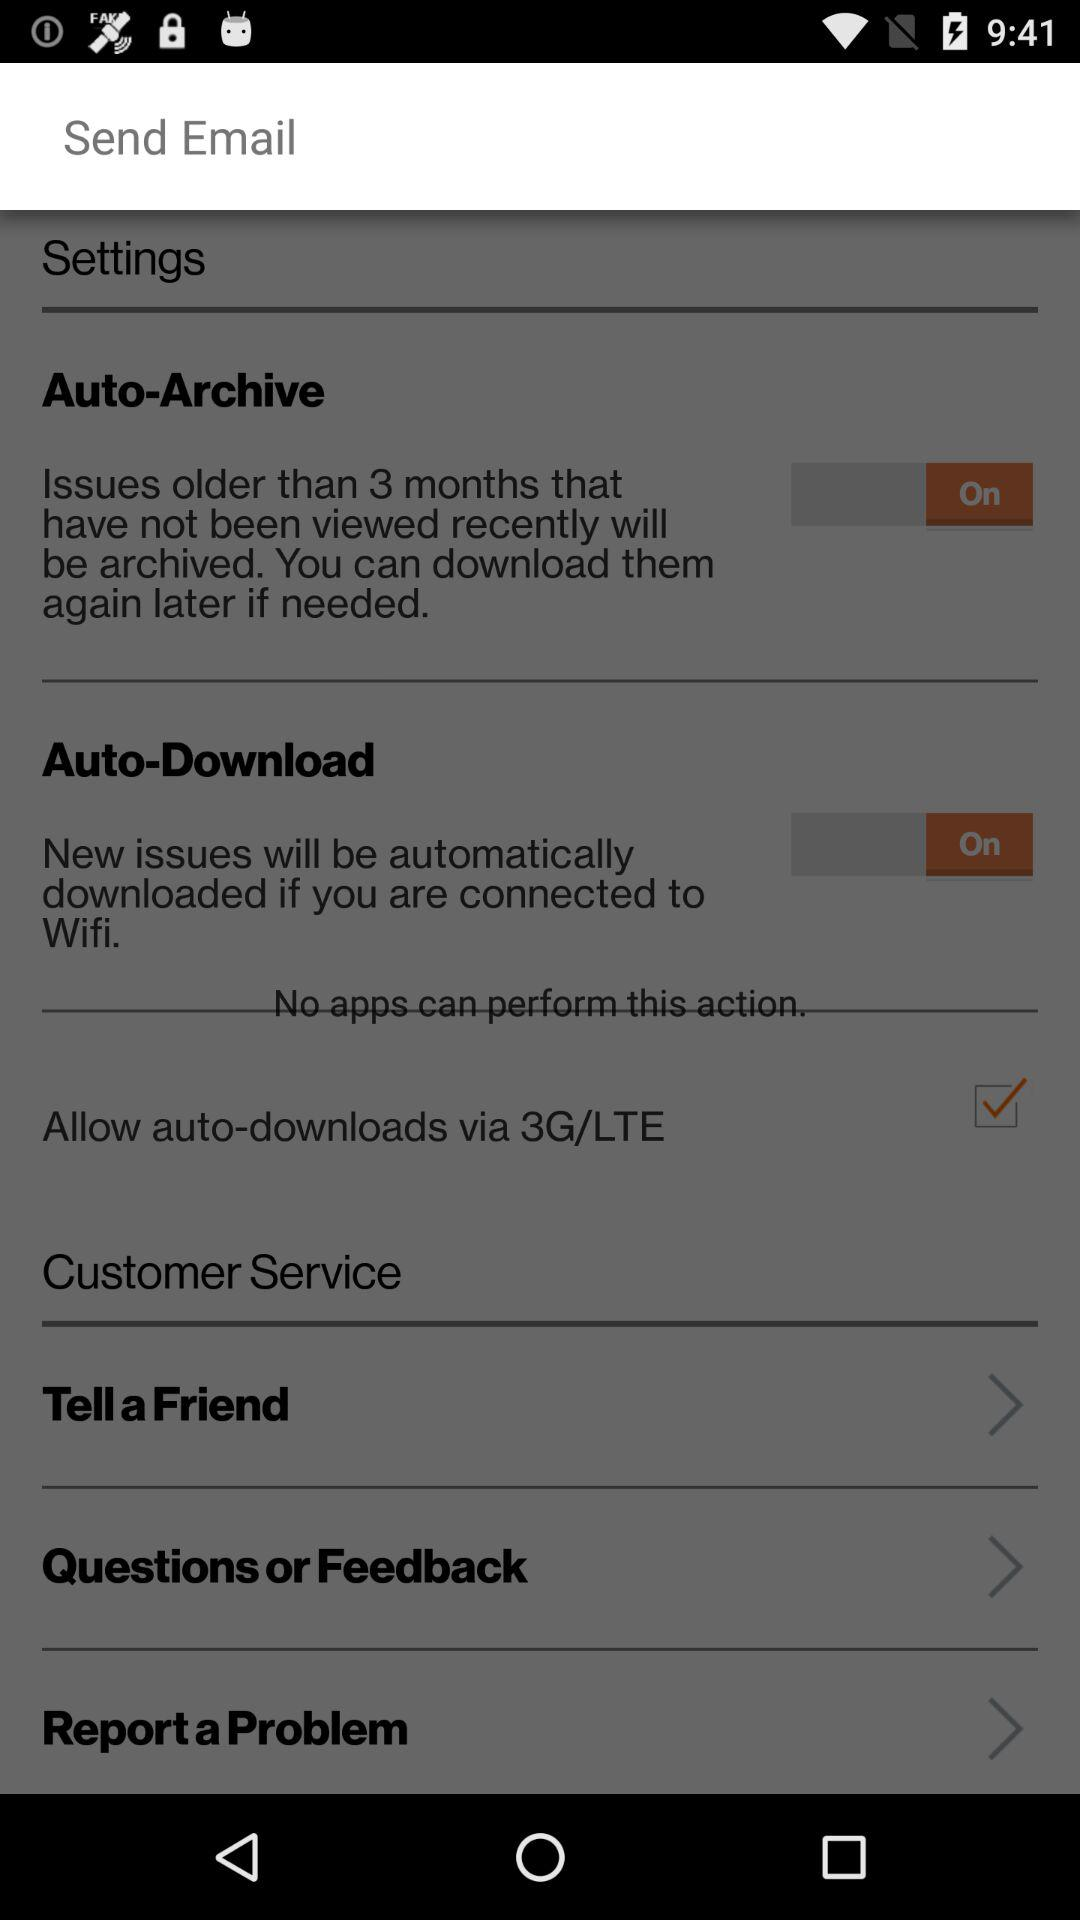What is the current status of the "Auto-Archive" setting? The status is "on". 